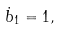Convert formula to latex. <formula><loc_0><loc_0><loc_500><loc_500>\dot { b } _ { 1 } = 1 ,</formula> 